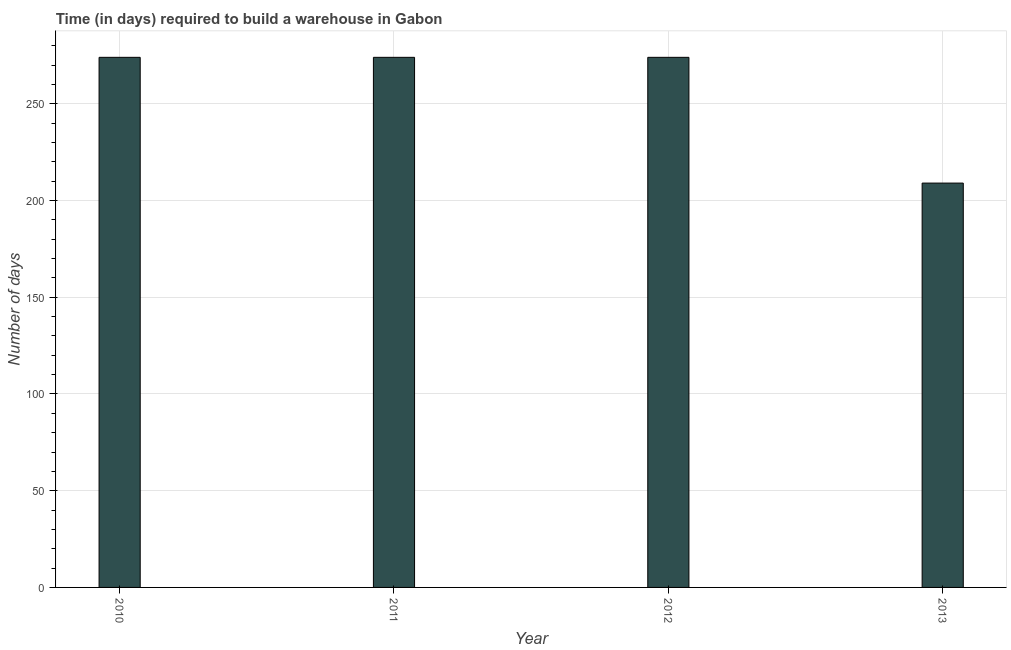Does the graph contain any zero values?
Keep it short and to the point. No. What is the title of the graph?
Ensure brevity in your answer.  Time (in days) required to build a warehouse in Gabon. What is the label or title of the Y-axis?
Your response must be concise. Number of days. What is the time required to build a warehouse in 2012?
Your answer should be very brief. 274. Across all years, what is the maximum time required to build a warehouse?
Offer a very short reply. 274. Across all years, what is the minimum time required to build a warehouse?
Your answer should be compact. 209. In which year was the time required to build a warehouse maximum?
Your answer should be compact. 2010. What is the sum of the time required to build a warehouse?
Offer a terse response. 1031. What is the difference between the time required to build a warehouse in 2011 and 2012?
Give a very brief answer. 0. What is the average time required to build a warehouse per year?
Give a very brief answer. 257. What is the median time required to build a warehouse?
Keep it short and to the point. 274. In how many years, is the time required to build a warehouse greater than 30 days?
Offer a very short reply. 4. Do a majority of the years between 2011 and 2010 (inclusive) have time required to build a warehouse greater than 20 days?
Offer a very short reply. No. Is the time required to build a warehouse in 2012 less than that in 2013?
Your answer should be compact. No. Is the difference between the time required to build a warehouse in 2010 and 2012 greater than the difference between any two years?
Ensure brevity in your answer.  No. Is the sum of the time required to build a warehouse in 2011 and 2013 greater than the maximum time required to build a warehouse across all years?
Your response must be concise. Yes. In how many years, is the time required to build a warehouse greater than the average time required to build a warehouse taken over all years?
Give a very brief answer. 3. Are the values on the major ticks of Y-axis written in scientific E-notation?
Provide a succinct answer. No. What is the Number of days in 2010?
Offer a terse response. 274. What is the Number of days of 2011?
Make the answer very short. 274. What is the Number of days of 2012?
Make the answer very short. 274. What is the Number of days in 2013?
Keep it short and to the point. 209. What is the difference between the Number of days in 2010 and 2011?
Offer a very short reply. 0. What is the difference between the Number of days in 2011 and 2012?
Make the answer very short. 0. What is the difference between the Number of days in 2012 and 2013?
Offer a very short reply. 65. What is the ratio of the Number of days in 2010 to that in 2012?
Provide a short and direct response. 1. What is the ratio of the Number of days in 2010 to that in 2013?
Provide a succinct answer. 1.31. What is the ratio of the Number of days in 2011 to that in 2013?
Give a very brief answer. 1.31. What is the ratio of the Number of days in 2012 to that in 2013?
Give a very brief answer. 1.31. 